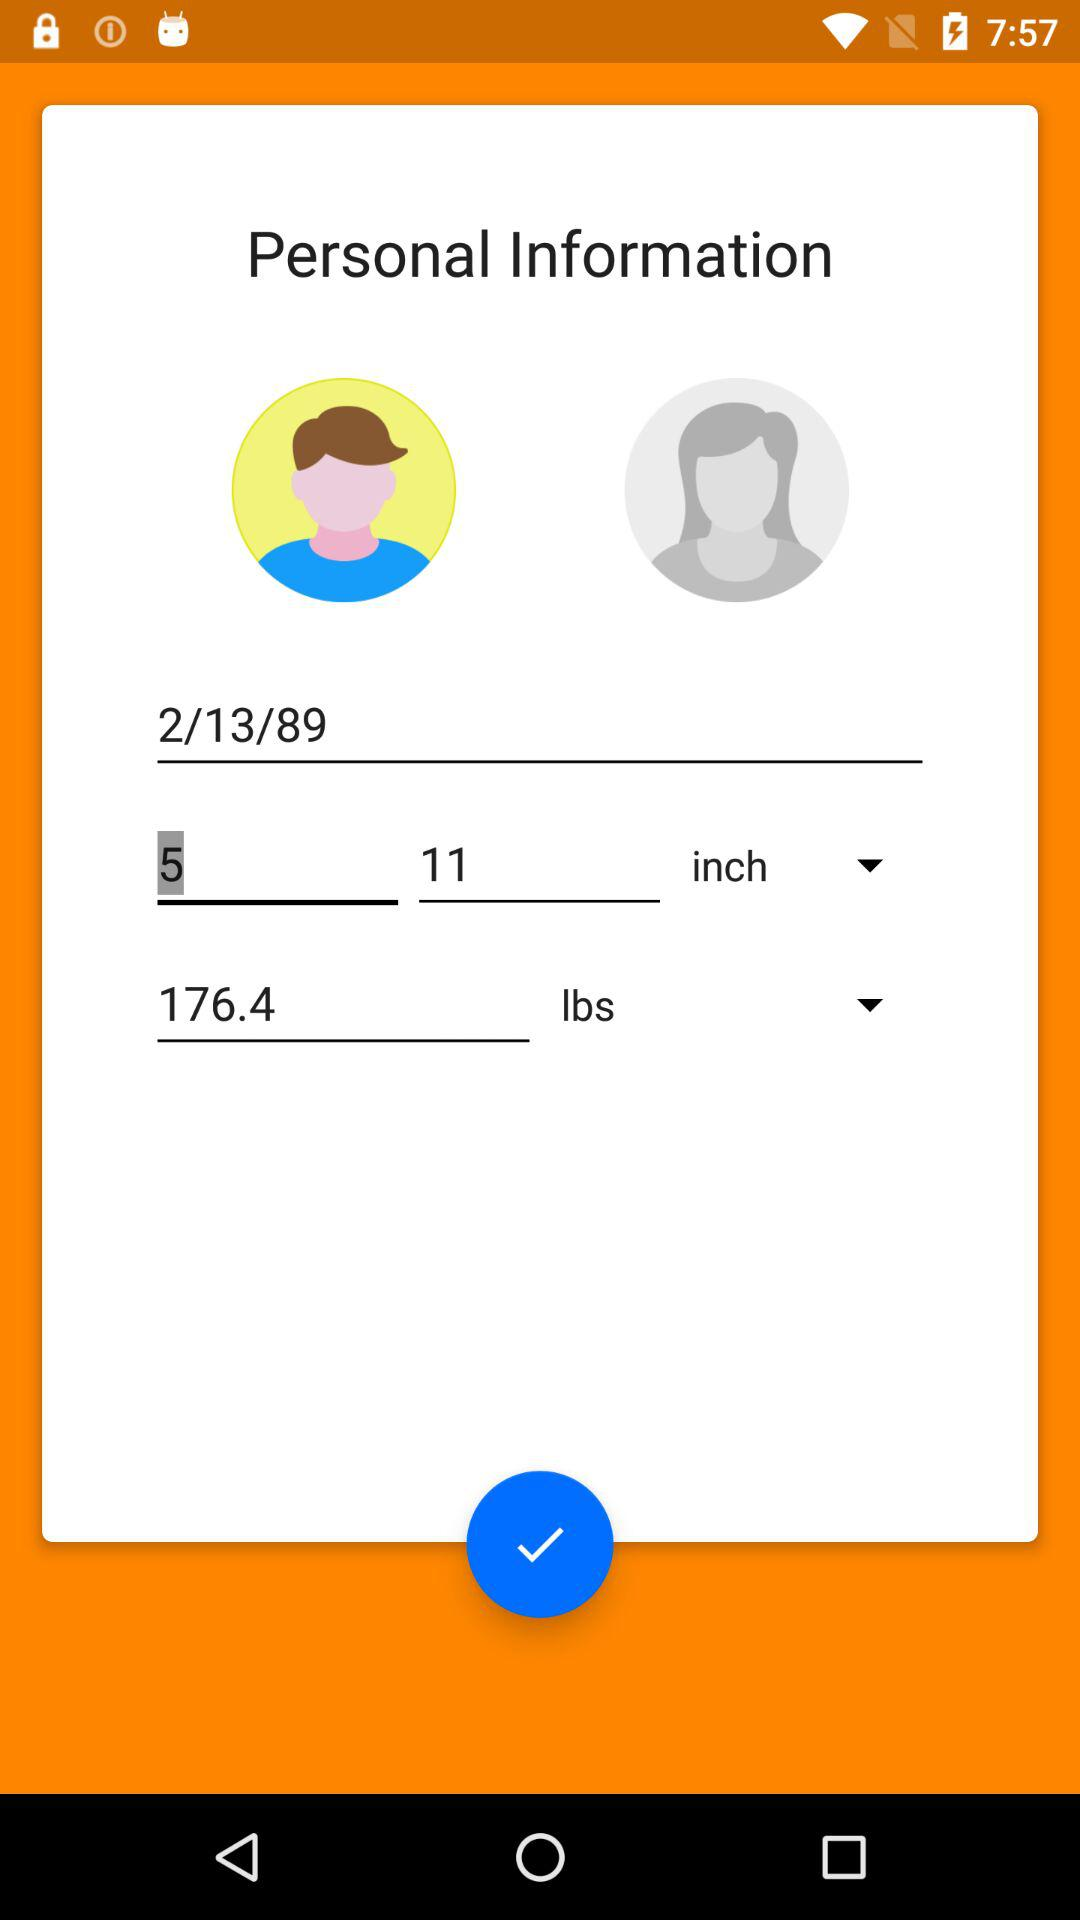How much taller is the person with the height of 11 inches than the person with the height of 5 inches?
Answer the question using a single word or phrase. 6 